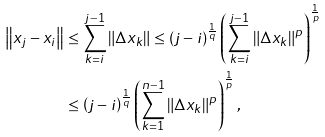<formula> <loc_0><loc_0><loc_500><loc_500>\left \| x _ { j } - x _ { i } \right \| & \leq \sum _ { k = i } ^ { j - 1 } \left \| \Delta x _ { k } \right \| \leq \left ( j - i \right ) ^ { \frac { 1 } { q } } \left ( \sum _ { k = i } ^ { j - 1 } \left \| \Delta x _ { k } \right \| ^ { p } \right ) ^ { \frac { 1 } { p } } \\ & \leq \left ( j - i \right ) ^ { \frac { 1 } { q } } \left ( \sum _ { k = 1 } ^ { n - 1 } \left \| \Delta x _ { k } \right \| ^ { p } \right ) ^ { \frac { 1 } { p } } ,</formula> 